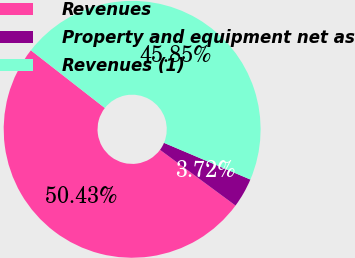<chart> <loc_0><loc_0><loc_500><loc_500><pie_chart><fcel>Revenues<fcel>Property and equipment net as<fcel>Revenues (1)<nl><fcel>50.43%<fcel>3.72%<fcel>45.85%<nl></chart> 